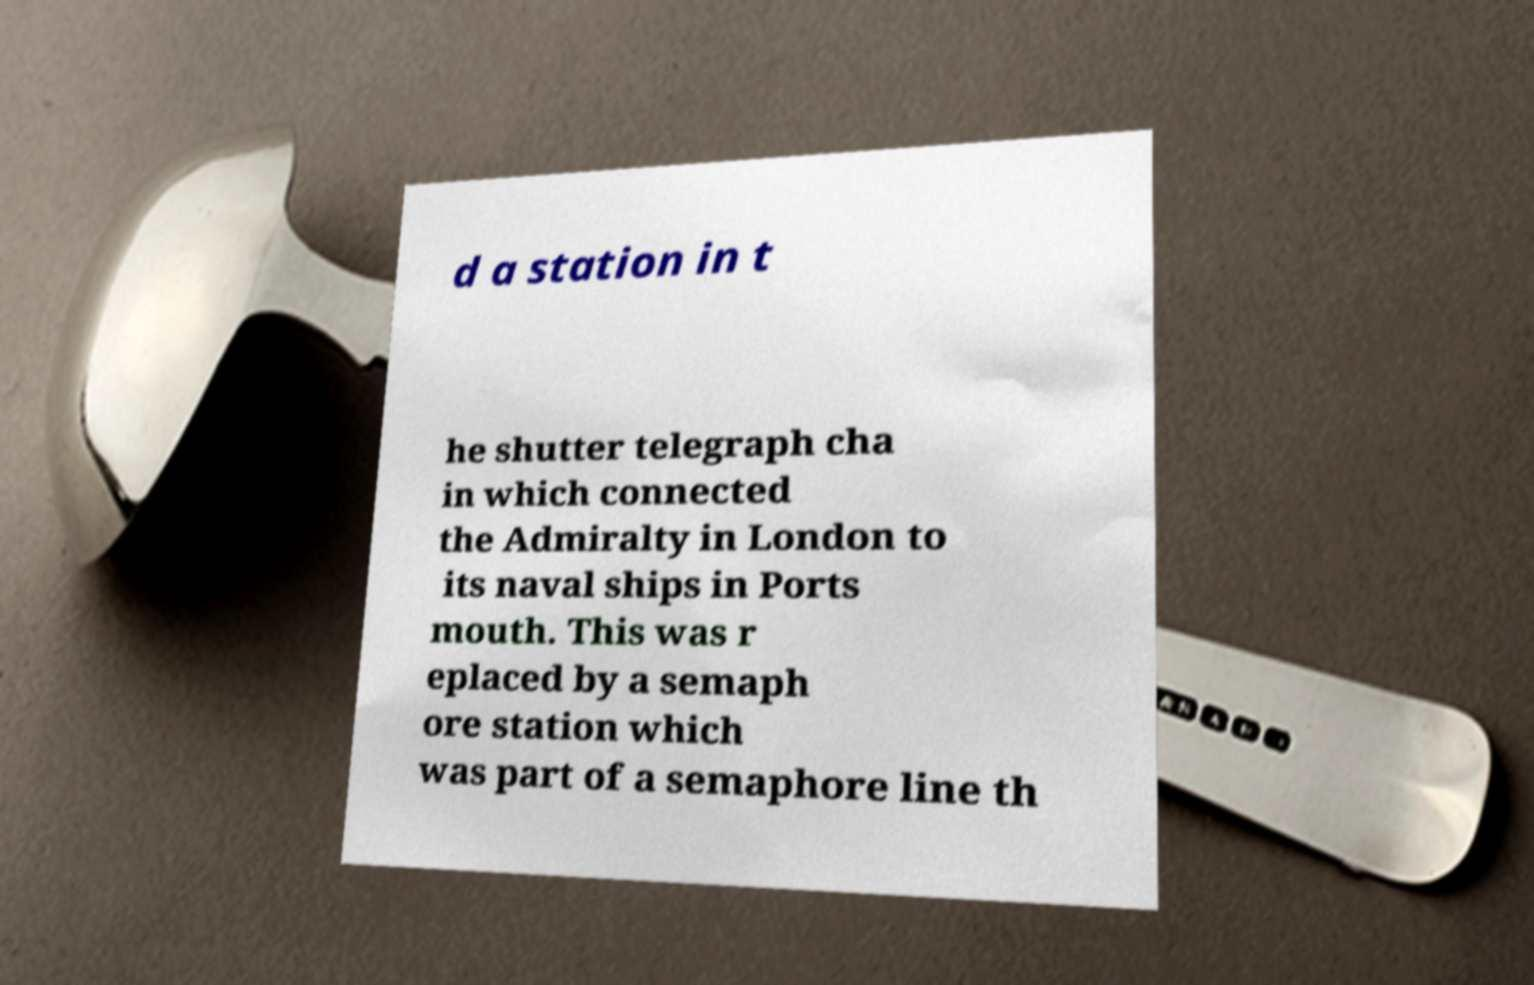For documentation purposes, I need the text within this image transcribed. Could you provide that? d a station in t he shutter telegraph cha in which connected the Admiralty in London to its naval ships in Ports mouth. This was r eplaced by a semaph ore station which was part of a semaphore line th 